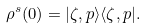<formula> <loc_0><loc_0><loc_500><loc_500>\rho ^ { s } ( 0 ) = | \zeta , p \rangle \langle \zeta , p | .</formula> 